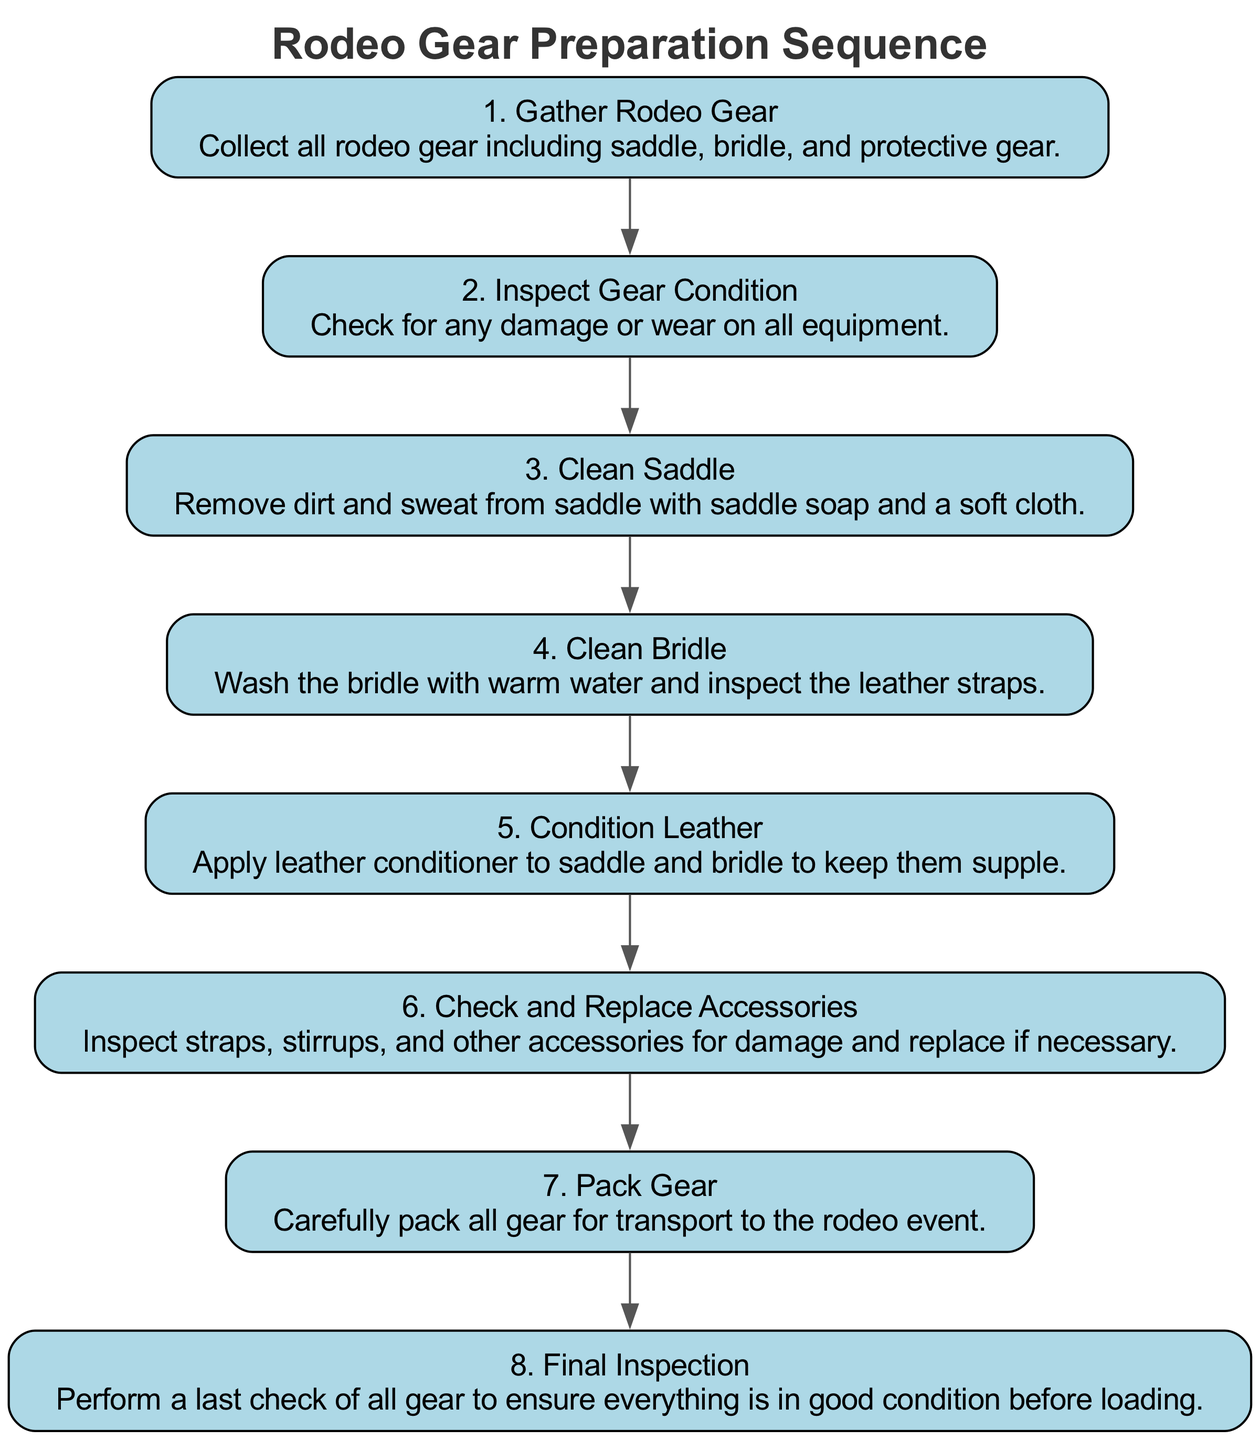What is the first step in preparing rodeo gear? The first step in the sequence diagram is "Gather Rodeo Gear," which indicates the collection of all necessary rodeo equipment. It's the initial action that starts the preparation process.
Answer: Gather Rodeo Gear How many steps are there in total for preparing rodeo gear? By counting the listed elements in the diagram, there are a total of eight steps involved in preparing rodeo gear.
Answer: 8 What step follows "Inspect Gear Condition"? The step that follows "Inspect Gear Condition" is "Clean Saddle." This shows the order of operations in caring for the rodeo gear.
Answer: Clean Saddle Which step involves applying leather conditioner? The step where leather conditioner is applied is called "Condition Leather." This action helps maintain the quality of the saddle and bridle in good condition.
Answer: Condition Leather Is "Final Inspection" the last step in the sequence? Yes, "Final Inspection" is indeed the last step in the sequence diagram, indicating the final check of gear before transport. This emphasizes the importance of ensuring the gear is in good working condition.
Answer: Yes How do you pack the gear after cleaning and conditioning? After the cleaning and conditioning steps, the gear is packed carefully as indicated by the "Pack Gear" step. This involves arranging everything for transport to the rodeo event following maintenance.
Answer: Pack Gear What does the "Check and Replace Accessories" step entail? The "Check and Replace Accessories" step involves inspecting various components of the gear, such as straps and stirrups, for any damage and replacing them if necessary to ensure safety and functionality.
Answer: Inspect straps, replace if necessary Which step comes before "Pack Gear"? The step that comes before "Pack Gear" is "Check and Replace Accessories." This sequence is vital to ensure everything is in proper order before organizing it for the event.
Answer: Check and Replace Accessories 